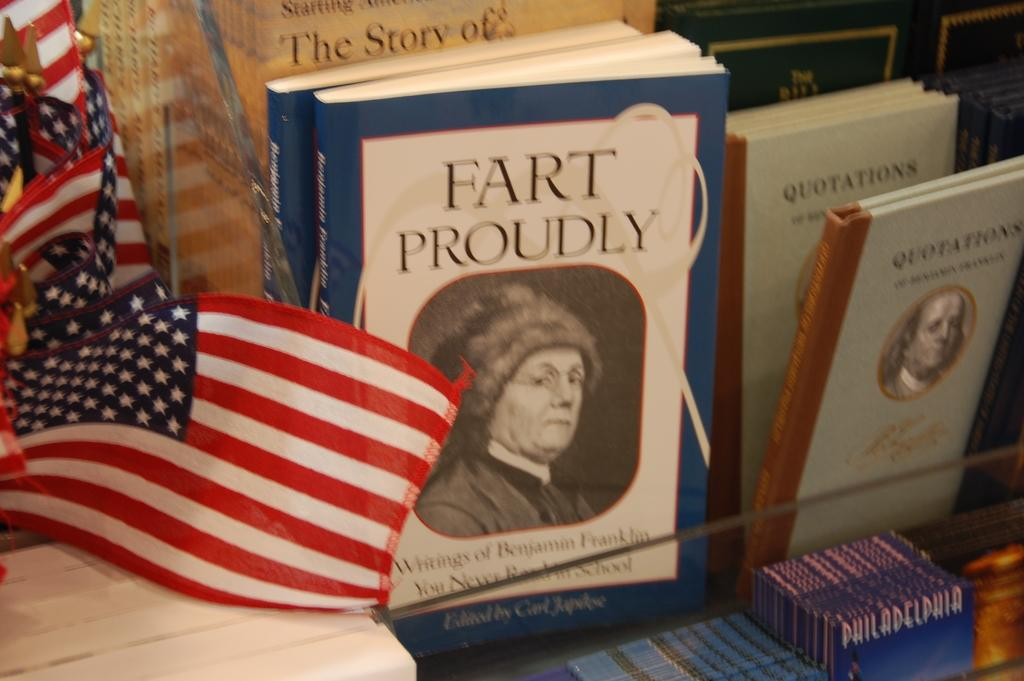<image>
Present a compact description of the photo's key features. A book titled, "Fart Proudly" is next to miniature American flags. 